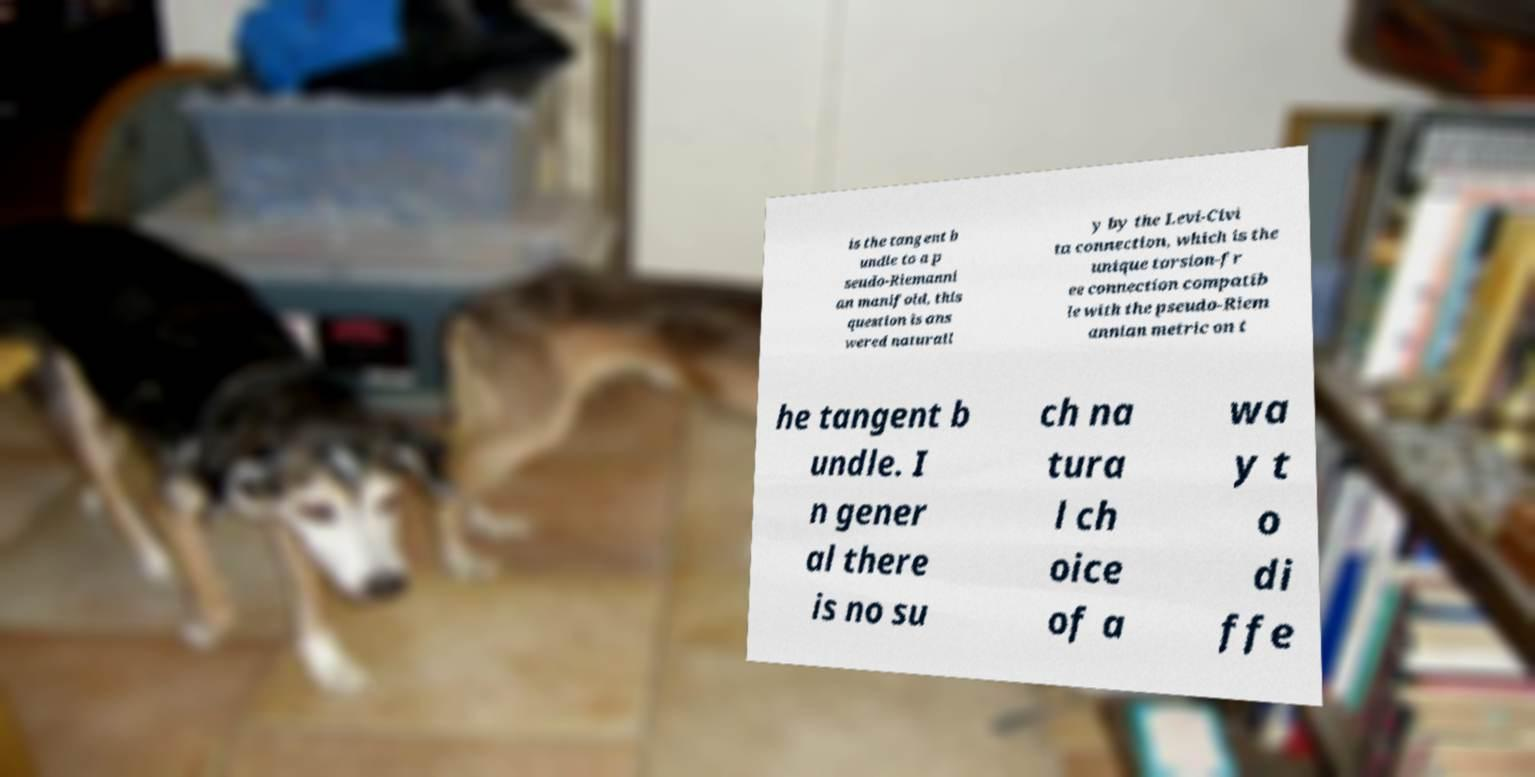Could you extract and type out the text from this image? is the tangent b undle to a p seudo-Riemanni an manifold, this question is ans wered naturall y by the Levi-Civi ta connection, which is the unique torsion-fr ee connection compatib le with the pseudo-Riem annian metric on t he tangent b undle. I n gener al there is no su ch na tura l ch oice of a wa y t o di ffe 